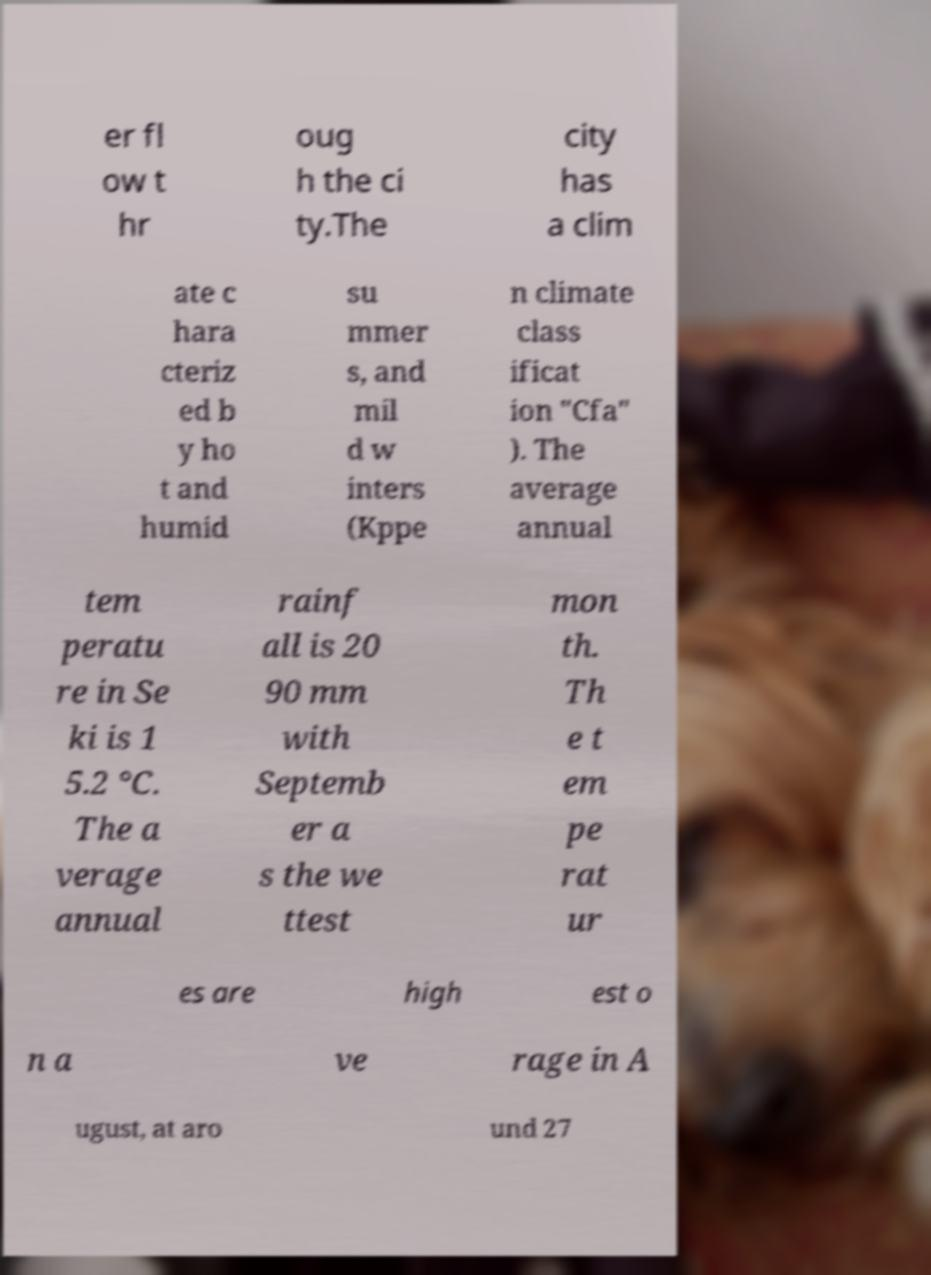Please read and relay the text visible in this image. What does it say? er fl ow t hr oug h the ci ty.The city has a clim ate c hara cteriz ed b y ho t and humid su mmer s, and mil d w inters (Kppe n climate class ificat ion "Cfa" ). The average annual tem peratu re in Se ki is 1 5.2 °C. The a verage annual rainf all is 20 90 mm with Septemb er a s the we ttest mon th. Th e t em pe rat ur es are high est o n a ve rage in A ugust, at aro und 27 